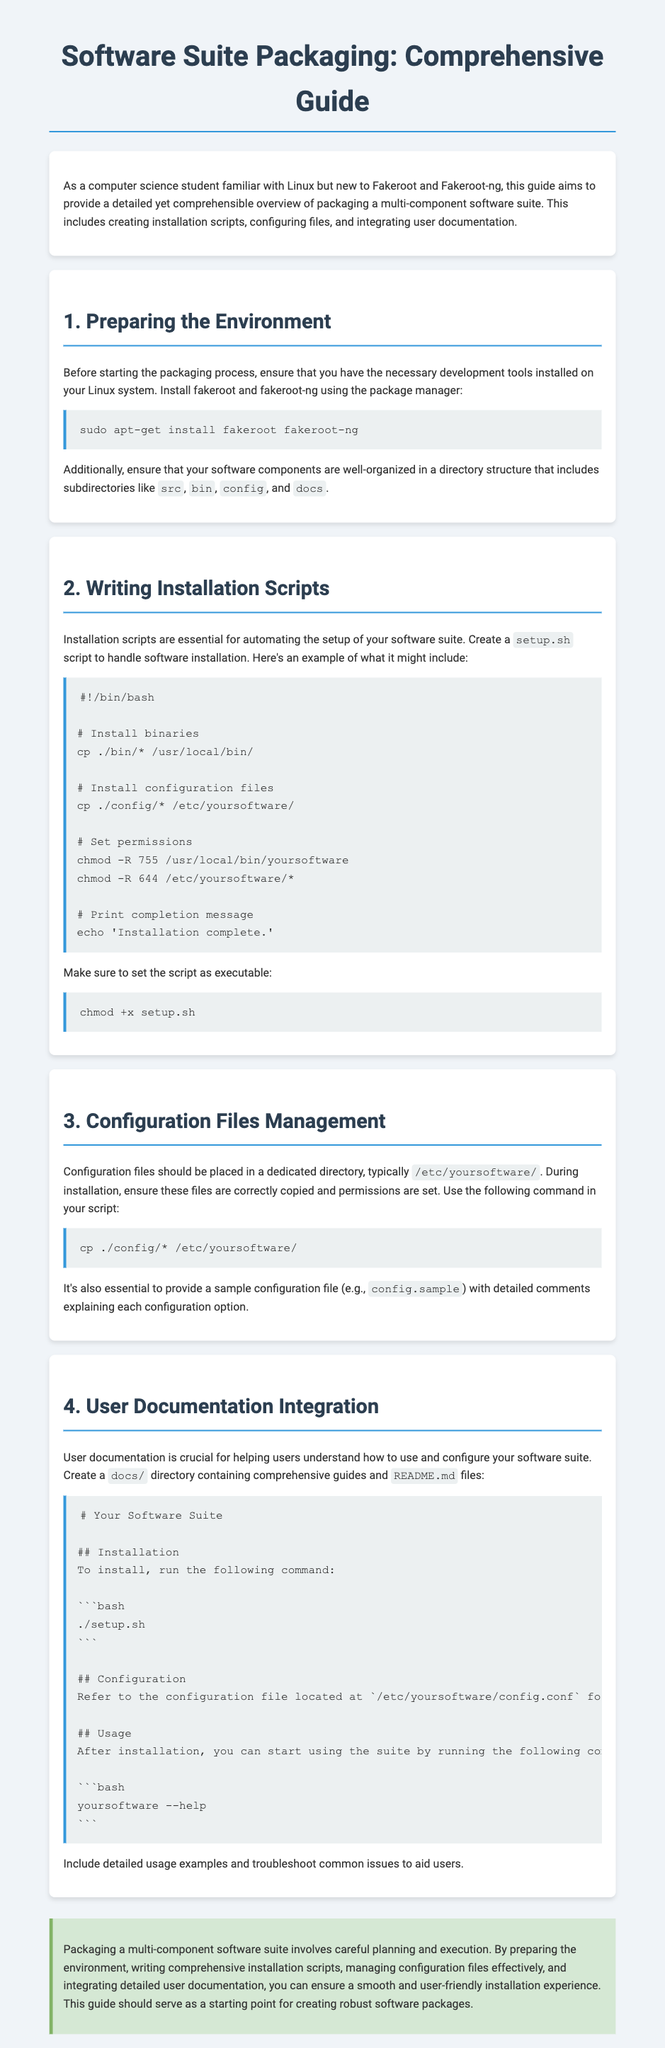What is the first step in the packaging process? The first step is to ensure that you have the necessary development tools installed on your Linux system.
Answer: Prepare the Environment What command installs fakeroot and fakeroot-ng? The command used to install these tools is included in the installation section of the document.
Answer: sudo apt-get install fakeroot fakeroot-ng What should be the name of the installation script? The document specifies an example name for the script that handles installation.
Answer: setup.sh Where should configuration files be placed during installation? The document outlines where configuration files should be located in the file system.
Answer: /etc/yoursoftware/ What is recommended to include in the docs directory? The document indicates the types of files and content that should be included in the documentation directory to help users.
Answer: Comprehensive guides and README.md files What type of file should contain detailed comments explaining configuration options? The guidance in the document specifies the type of file that should include explanations for configuration settings.
Answer: config.sample What permissions should be set for the installed binaries? The document provides specific permissions that should be applied to the binaries after installation.
Answer: 755 What is one purpose of user documentation? The document highlights a key function of user documentation for a software suite.
Answer: Helping users understand how to use and configure the software What command is provided to start using the software after installation? The installation instructions include a command that users can run to begin using the software.
Answer: yoursoftware --help 